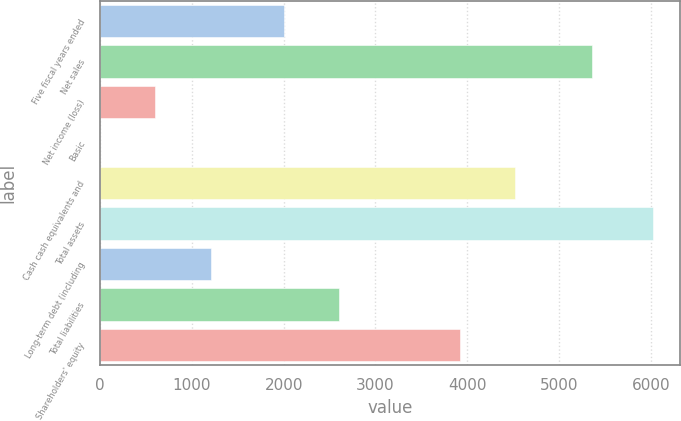<chart> <loc_0><loc_0><loc_500><loc_500><bar_chart><fcel>Five fiscal years ended<fcel>Net sales<fcel>Net income (loss)<fcel>Basic<fcel>Cash cash equivalents and<fcel>Total assets<fcel>Long-term debt (including<fcel>Total liabilities<fcel>Shareholders' equity<nl><fcel>2001<fcel>5363<fcel>602.16<fcel>0.07<fcel>4522.09<fcel>6021<fcel>1204.25<fcel>2603.09<fcel>3920<nl></chart> 